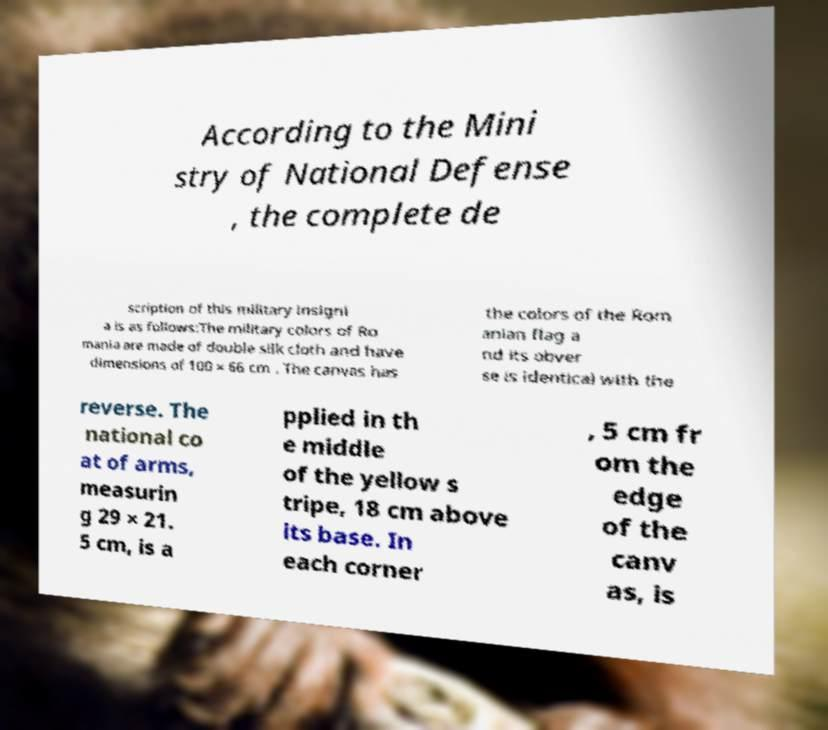Could you extract and type out the text from this image? According to the Mini stry of National Defense , the complete de scription of this military insigni a is as follows:The military colors of Ro mania are made of double silk cloth and have dimensions of 100 × 66 cm . The canvas has the colors of the Rom anian flag a nd its obver se is identical with the reverse. The national co at of arms, measurin g 29 × 21. 5 cm, is a pplied in th e middle of the yellow s tripe, 18 cm above its base. In each corner , 5 cm fr om the edge of the canv as, is 